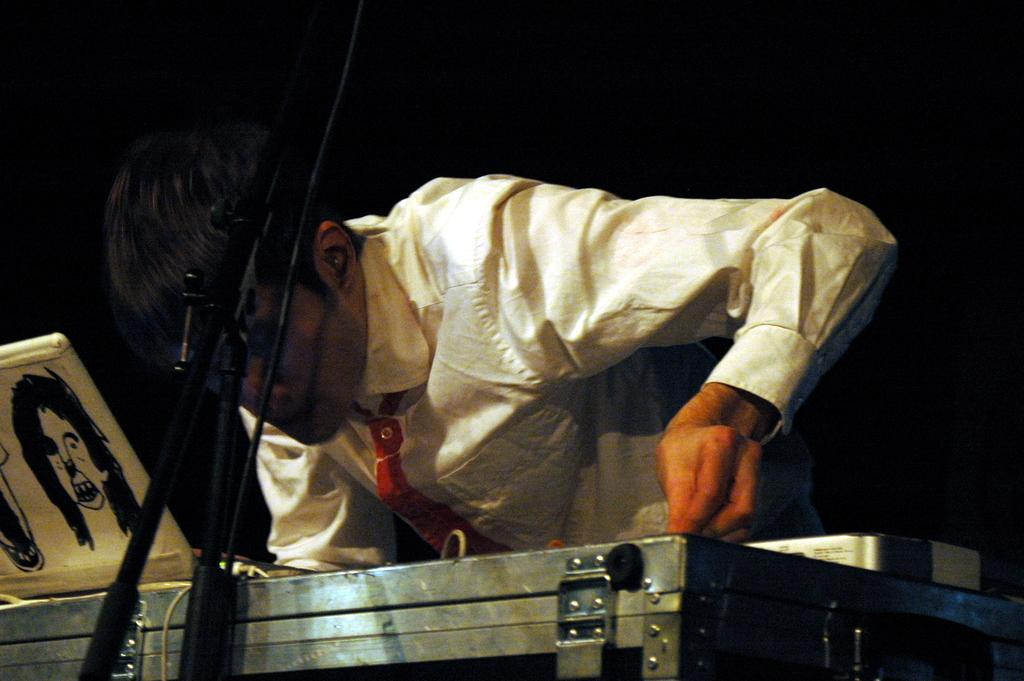What is the main subject in the image? There is a person standing in the image. What is located at the bottom of the image? There is a box at the bottom of the image. What is placed on the box? There are containers and a laptop on the box. What object is in the foreground of the image? There is a microphone in the foreground of the image. What type of lettuce is being used as a string to hold the containers on the box? There is no lettuce or string present in the image; the containers are simply placed on the box. 